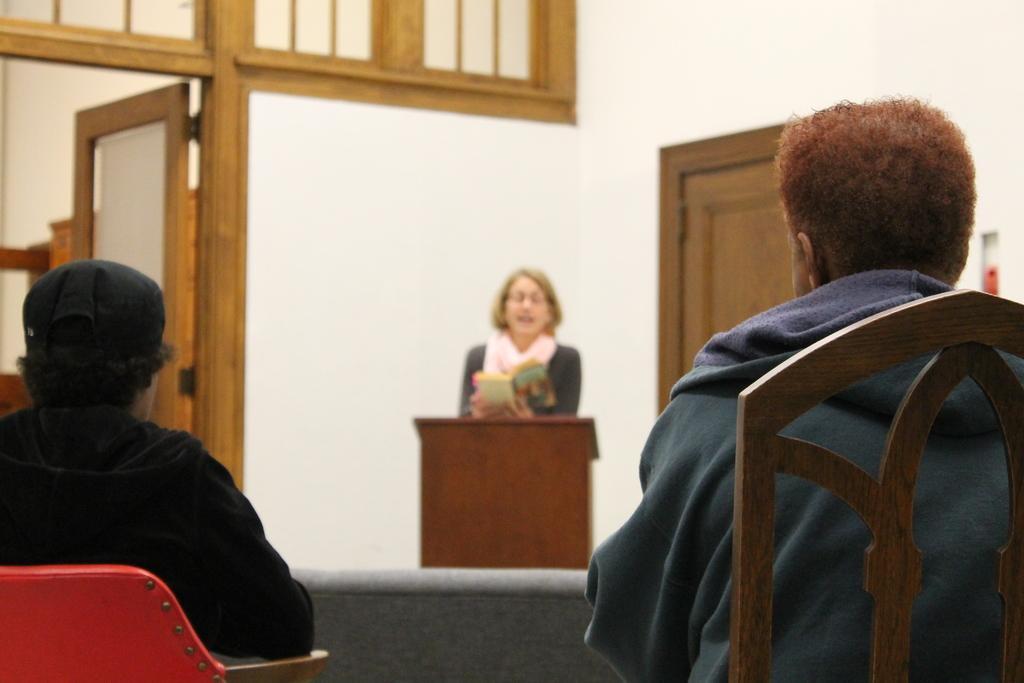Please provide a concise description of this image. In this picture there are two persons sitting on the chair. this is podium. Behind the podium a person standing and reading book. In this background we can see wall and door. 